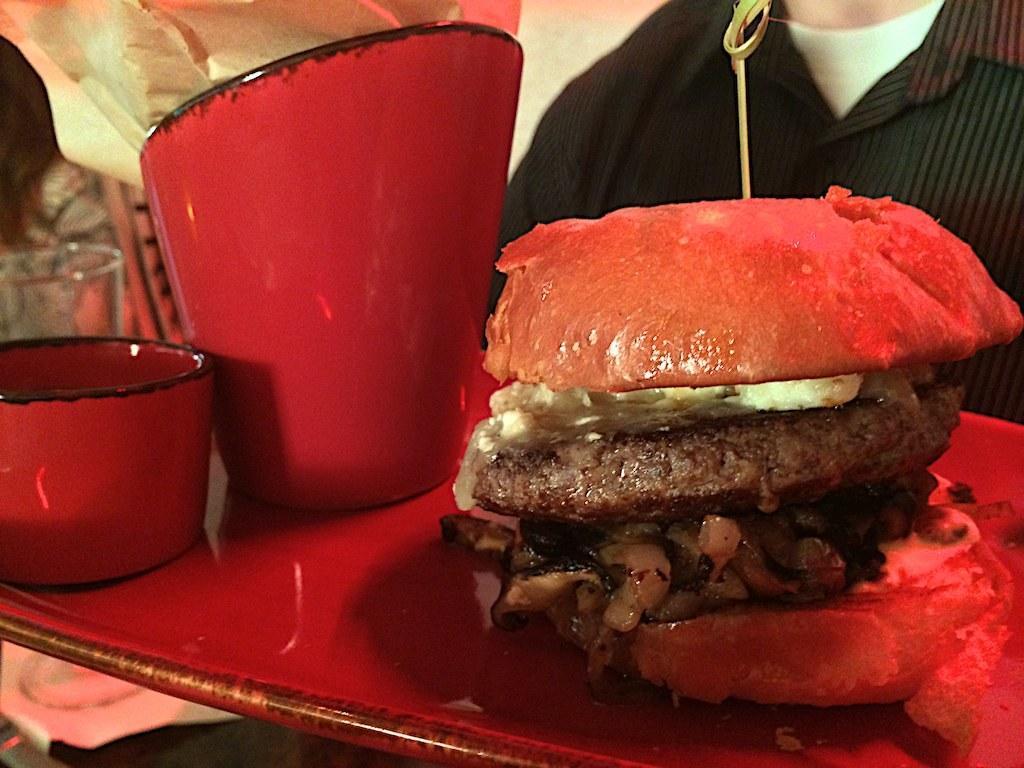In one or two sentences, can you explain what this image depicts? In this image we can see burger, cup, bowl on the tray. In the background we can see a person and other objects. 